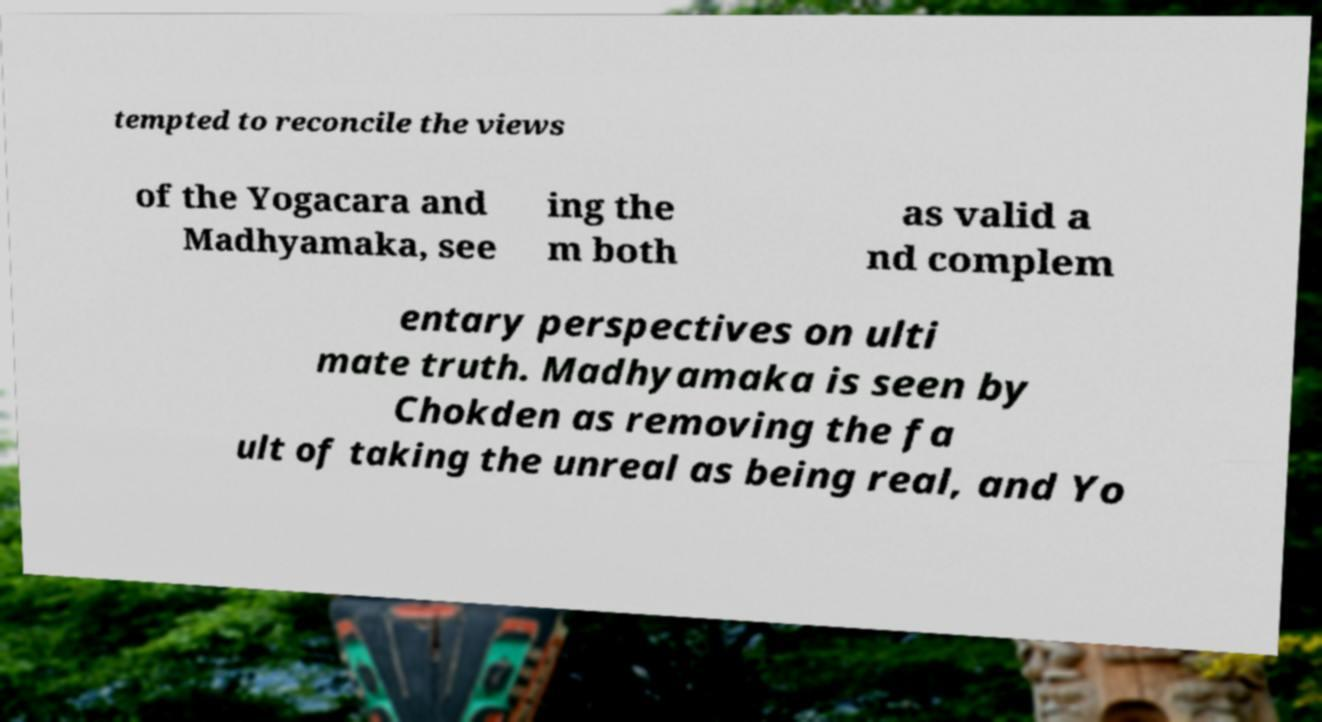Could you assist in decoding the text presented in this image and type it out clearly? tempted to reconcile the views of the Yogacara and Madhyamaka, see ing the m both as valid a nd complem entary perspectives on ulti mate truth. Madhyamaka is seen by Chokden as removing the fa ult of taking the unreal as being real, and Yo 